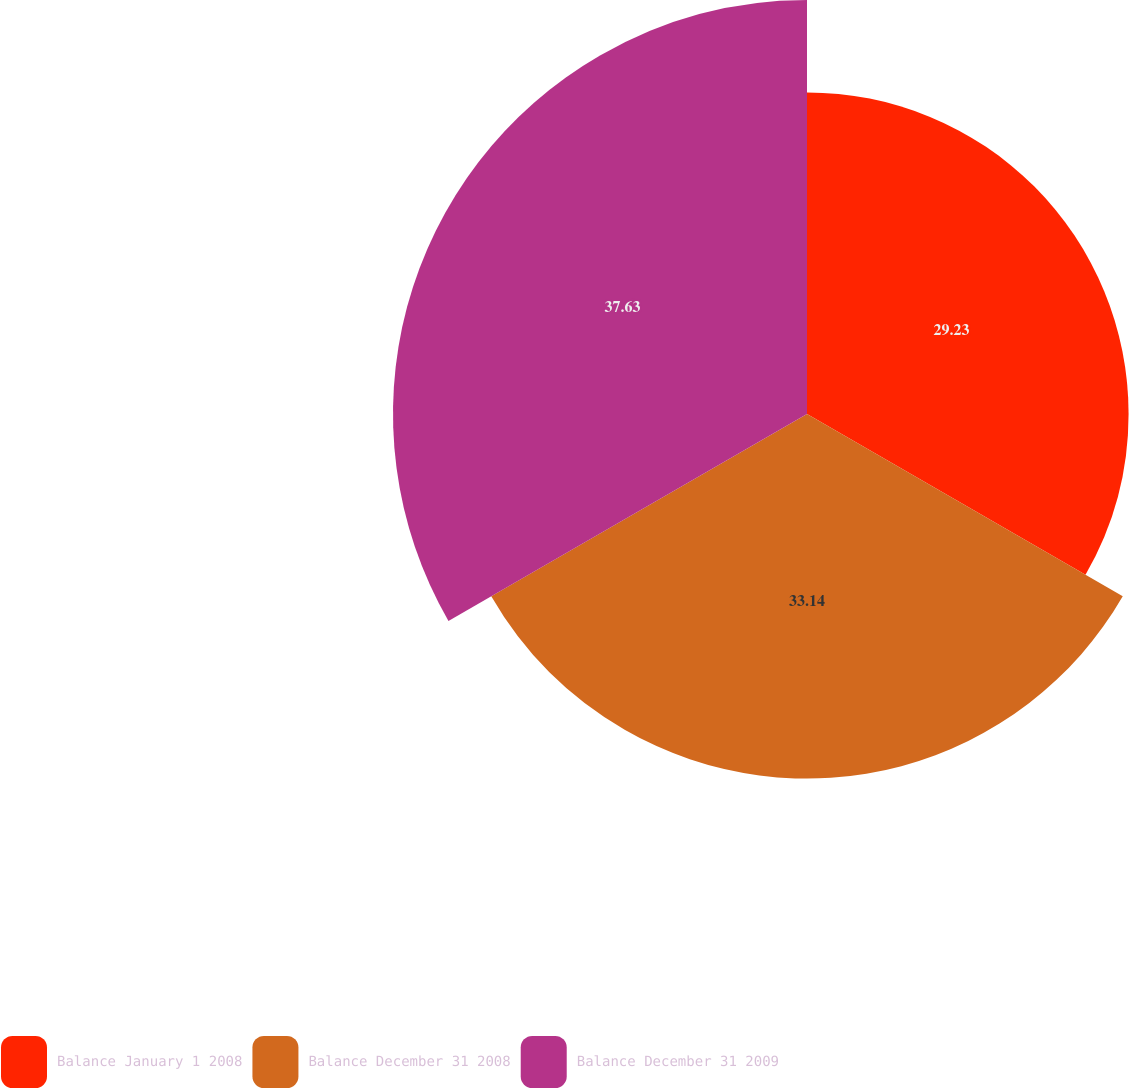<chart> <loc_0><loc_0><loc_500><loc_500><pie_chart><fcel>Balance January 1 2008<fcel>Balance December 31 2008<fcel>Balance December 31 2009<nl><fcel>29.23%<fcel>33.14%<fcel>37.63%<nl></chart> 